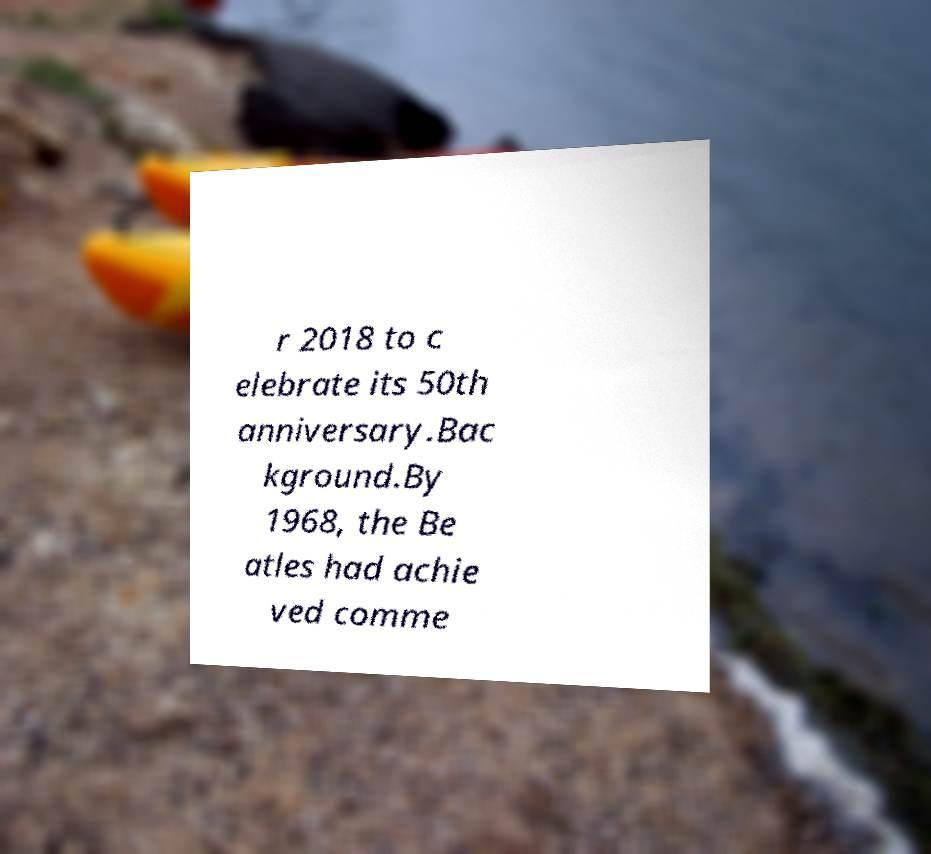Can you accurately transcribe the text from the provided image for me? r 2018 to c elebrate its 50th anniversary.Bac kground.By 1968, the Be atles had achie ved comme 